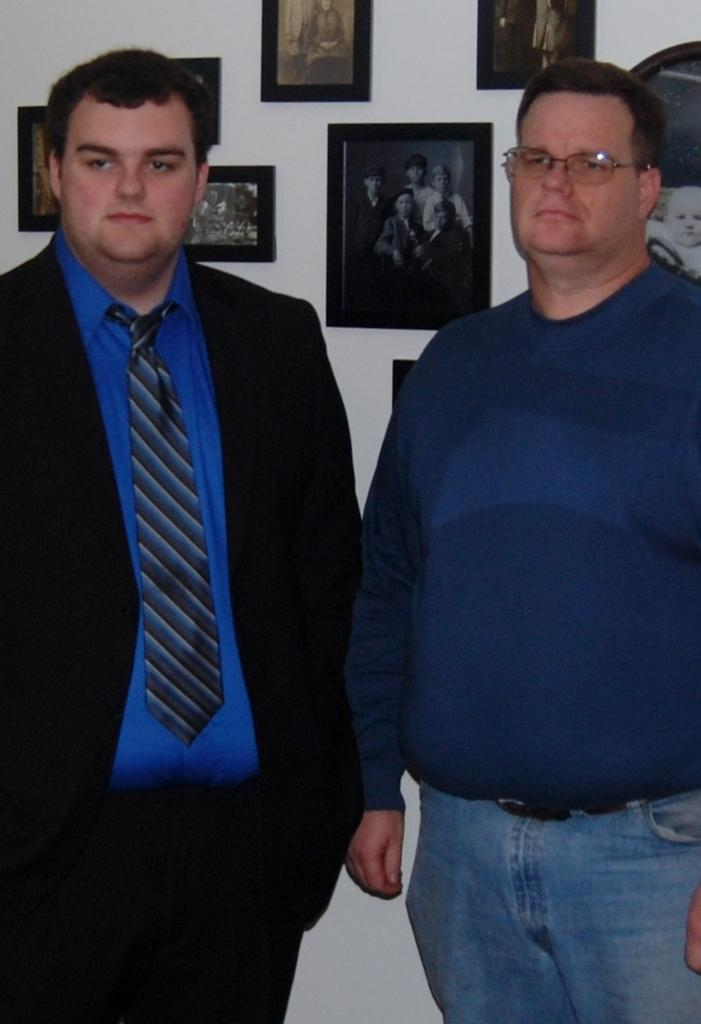How many people are in the image? There are two men standing in the image. What is one of the men wearing? One of the men is wearing a suit. What can be seen in the background of the image? There is a white wall in the background. What is on the white wall? The white wall has many photo frames on it. What type of doctor is standing next to the man in the suit? There is no doctor present in the image. How does the heat affect the men in the image? The provided facts do not mention any heat or temperature-related information, so we cannot determine how it affects the men in the image. 